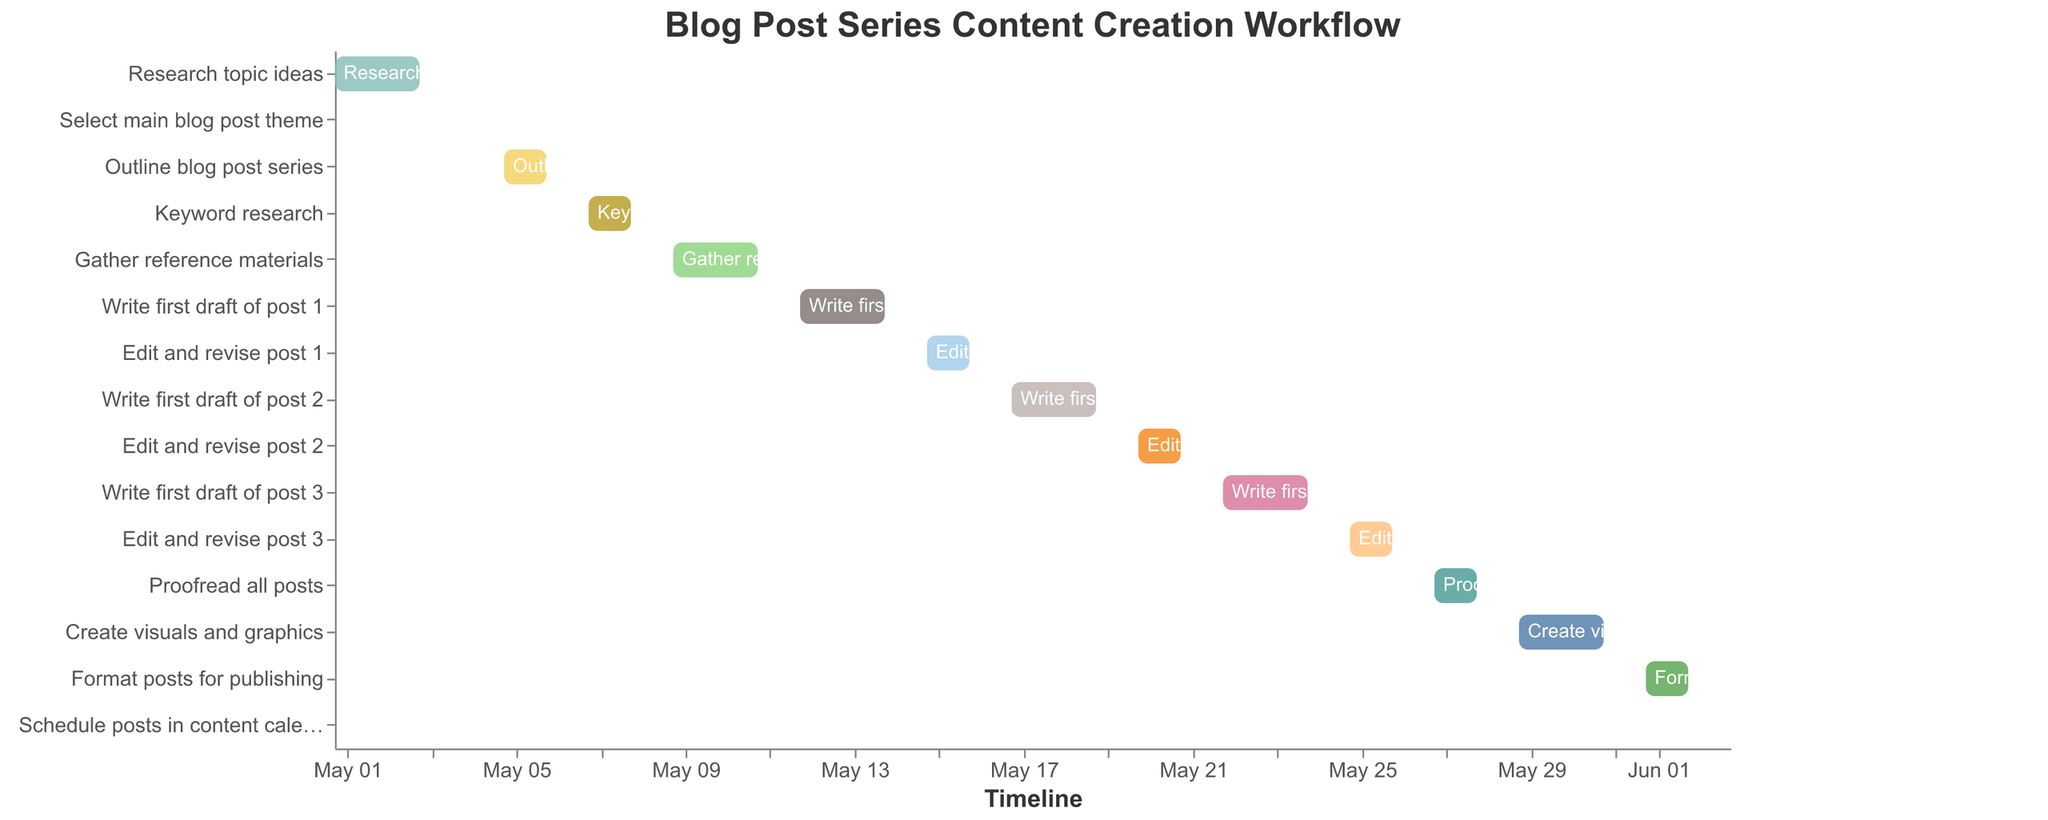What is the duration of the task "Research topic ideas"? Look for the "Research topic ideas" task and note the duration mentioned.
Answer: 3 days On what date does the "Write first draft of post 2" finish? Locate the task "Write first draft of post 2" and refer to the "End Date" column to find the end date.
Answer: 2023-05-19 Which task has the shortest duration? Find the task with the smallest duration value listed in the Duration column.
Answer: Select main blog post theme How many tasks last for exactly 2 days? Count the number of tasks that have a duration value of 2 days.
Answer: 6 tasks What tasks are performed immediately after "Gather reference materials"? Identify the next task's "Start Date" which is immediately following the "End Date" of "Gather reference materials".
Answer: Write first draft of post 1 Which tasks have overlapping timelines with "Edit and revise post 2"? Check the start and end dates of tasks that coincide or overlap with the start and end date of "Edit and revise post 2" (2023-05-20 to 2023-05-21).
Answer: Write first draft of post 3 What is the total duration for writing all the first drafts? Add the duration of all tasks that involve "Write first draft" (post 1, post 2, and post 3).
Answer: 9 days How many tasks start in the month of May? Count the number of tasks whose "Start Date" lies within the month of May.
Answer: 14 tasks Which task ends on June 2nd, 2023? Locate the "End Date" which matches June 2nd, 2023 and find the corresponding task.
Answer: Format posts for publishing What is the date range for the "Create visuals and graphics" task? Identify the start and end date for the "Create visuals and graphics" task in the figure.
Answer: May 29 - May 31 